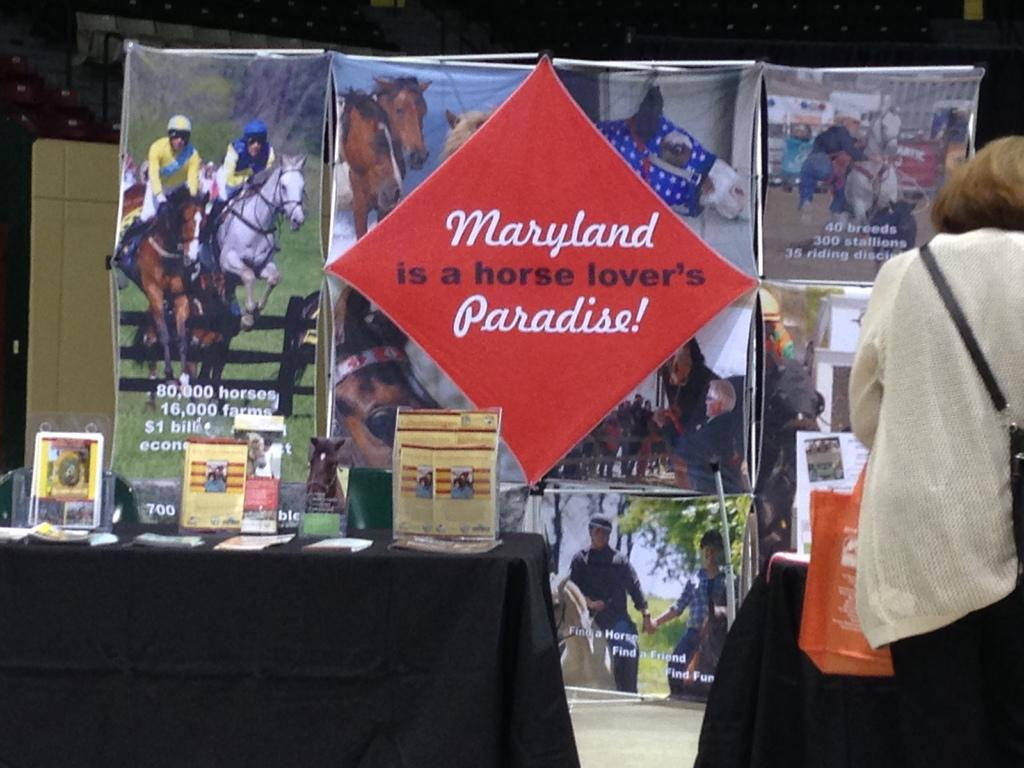<image>
Share a concise interpretation of the image provided. Several photos of horses are behind a sign that says Maryland is a horse lover's paradise. 